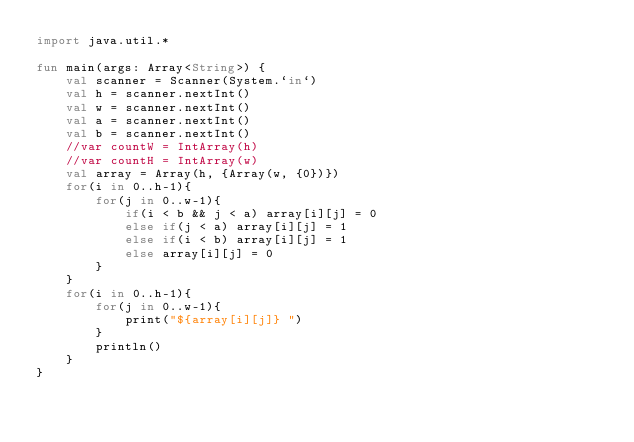<code> <loc_0><loc_0><loc_500><loc_500><_Kotlin_>import java.util.*

fun main(args: Array<String>) {
    val scanner = Scanner(System.`in`)
    val h = scanner.nextInt()
    val w = scanner.nextInt()
    val a = scanner.nextInt()
    val b = scanner.nextInt()
    //var countW = IntArray(h)
    //var countH = IntArray(w)
    val array = Array(h, {Array(w, {0})})
    for(i in 0..h-1){
        for(j in 0..w-1){
            if(i < b && j < a) array[i][j] = 0
            else if(j < a) array[i][j] = 1
            else if(i < b) array[i][j] = 1
            else array[i][j] = 0
        }
    }
    for(i in 0..h-1){
        for(j in 0..w-1){
            print("${array[i][j]} ")
        }
        println()
    }
}</code> 